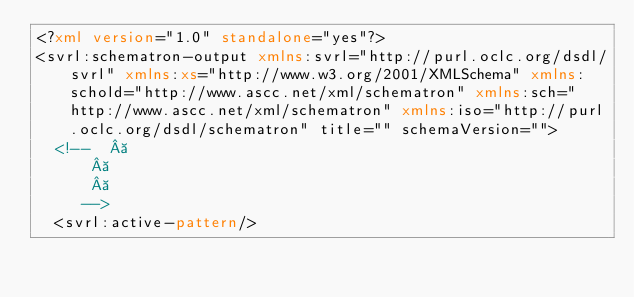<code> <loc_0><loc_0><loc_500><loc_500><_XML_><?xml version="1.0" standalone="yes"?>
<svrl:schematron-output xmlns:svrl="http://purl.oclc.org/dsdl/svrl" xmlns:xs="http://www.w3.org/2001/XMLSchema" xmlns:schold="http://www.ascc.net/xml/schematron" xmlns:sch="http://www.ascc.net/xml/schematron" xmlns:iso="http://purl.oclc.org/dsdl/schematron" title="" schemaVersion="">
  <!--   
		   
		   
		 -->
  <svrl:active-pattern/></code> 